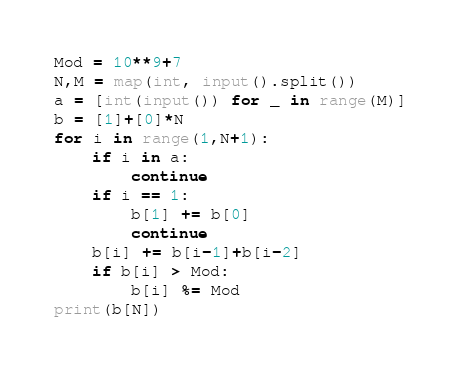<code> <loc_0><loc_0><loc_500><loc_500><_Python_>Mod = 10**9+7
N,M = map(int, input().split())
a = [int(input()) for _ in range(M)]
b = [1]+[0]*N
for i in range(1,N+1):
    if i in a:
        continue
    if i == 1:
        b[1] += b[0]
        continue
    b[i] += b[i-1]+b[i-2]
    if b[i] > Mod:
        b[i] %= Mod
print(b[N])</code> 